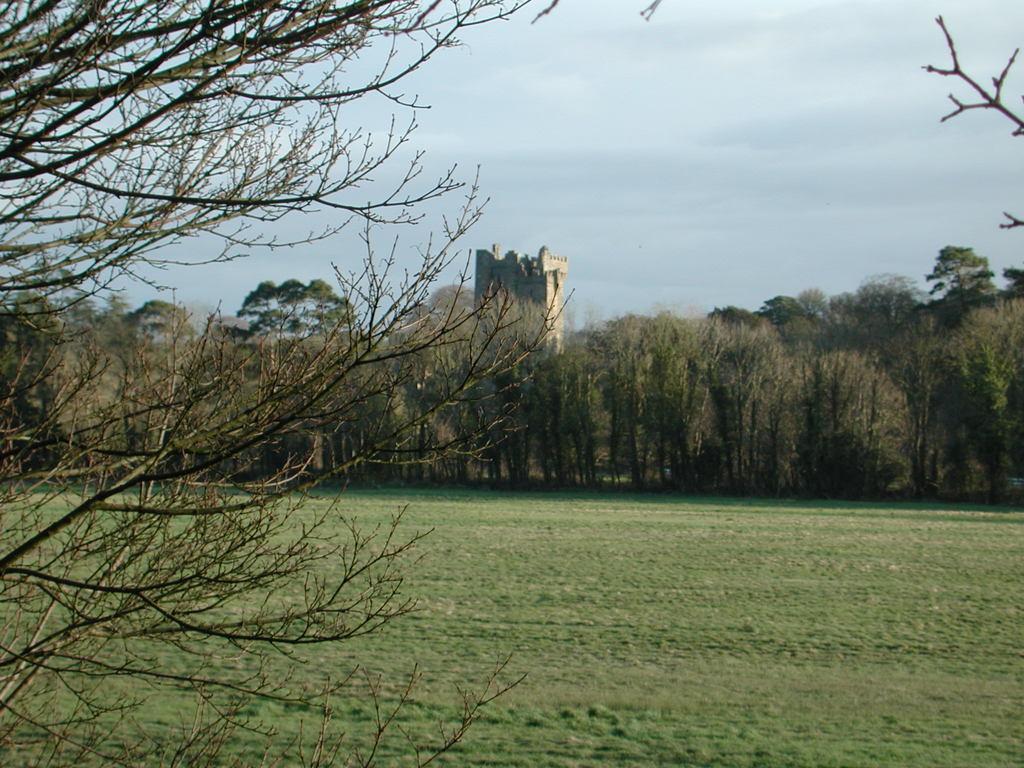Can you describe this image briefly? At the bottom of the image we can see grass. In the middle of the image we can see some trees and castle. At the top of the image we can see some clouds in the sky. 